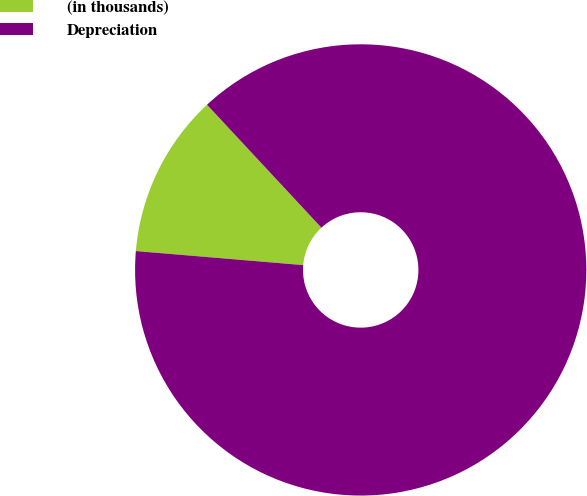Convert chart. <chart><loc_0><loc_0><loc_500><loc_500><pie_chart><fcel>(in thousands)<fcel>Depreciation<nl><fcel>11.74%<fcel>88.26%<nl></chart> 